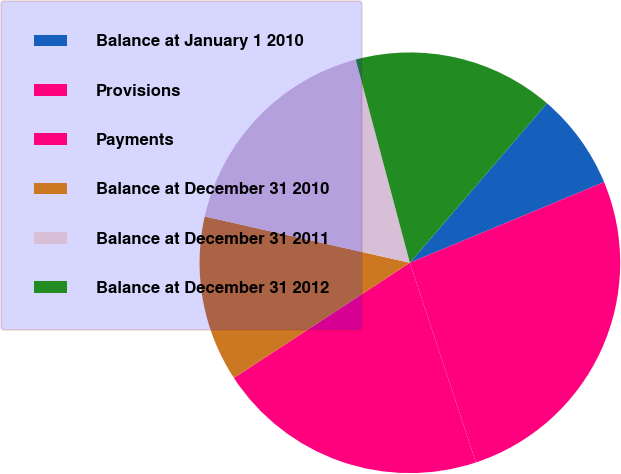<chart> <loc_0><loc_0><loc_500><loc_500><pie_chart><fcel>Balance at January 1 2010<fcel>Provisions<fcel>Payments<fcel>Balance at December 31 2010<fcel>Balance at December 31 2011<fcel>Balance at December 31 2012<nl><fcel>7.44%<fcel>26.18%<fcel>20.86%<fcel>12.76%<fcel>17.32%<fcel>15.44%<nl></chart> 